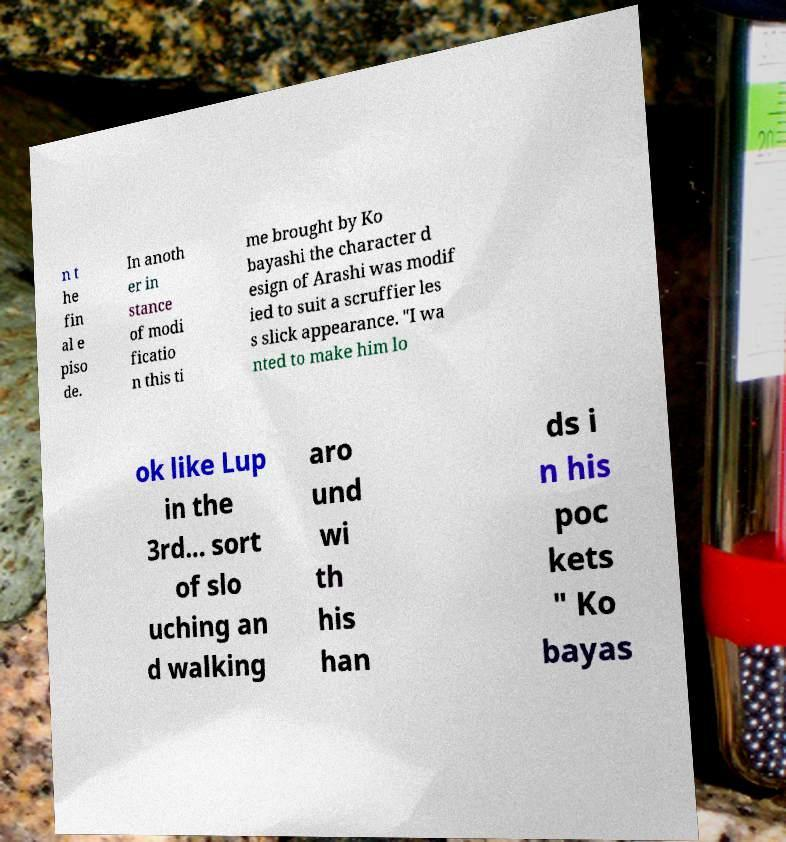Can you accurately transcribe the text from the provided image for me? n t he fin al e piso de. In anoth er in stance of modi ficatio n this ti me brought by Ko bayashi the character d esign of Arashi was modif ied to suit a scruffier les s slick appearance. "I wa nted to make him lo ok like Lup in the 3rd... sort of slo uching an d walking aro und wi th his han ds i n his poc kets " Ko bayas 